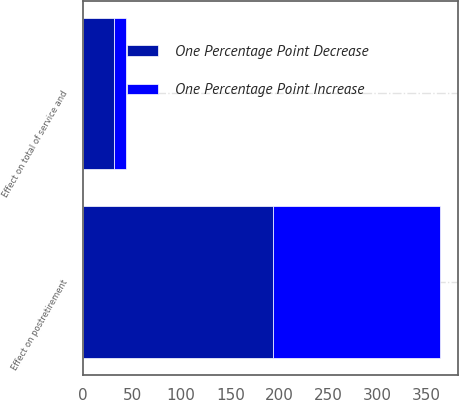Convert chart to OTSL. <chart><loc_0><loc_0><loc_500><loc_500><stacked_bar_chart><ecel><fcel>Effect on total of service and<fcel>Effect on postretirement<nl><fcel>One Percentage Point Decrease<fcel>32<fcel>194<nl><fcel>One Percentage Point Increase<fcel>12<fcel>170<nl></chart> 